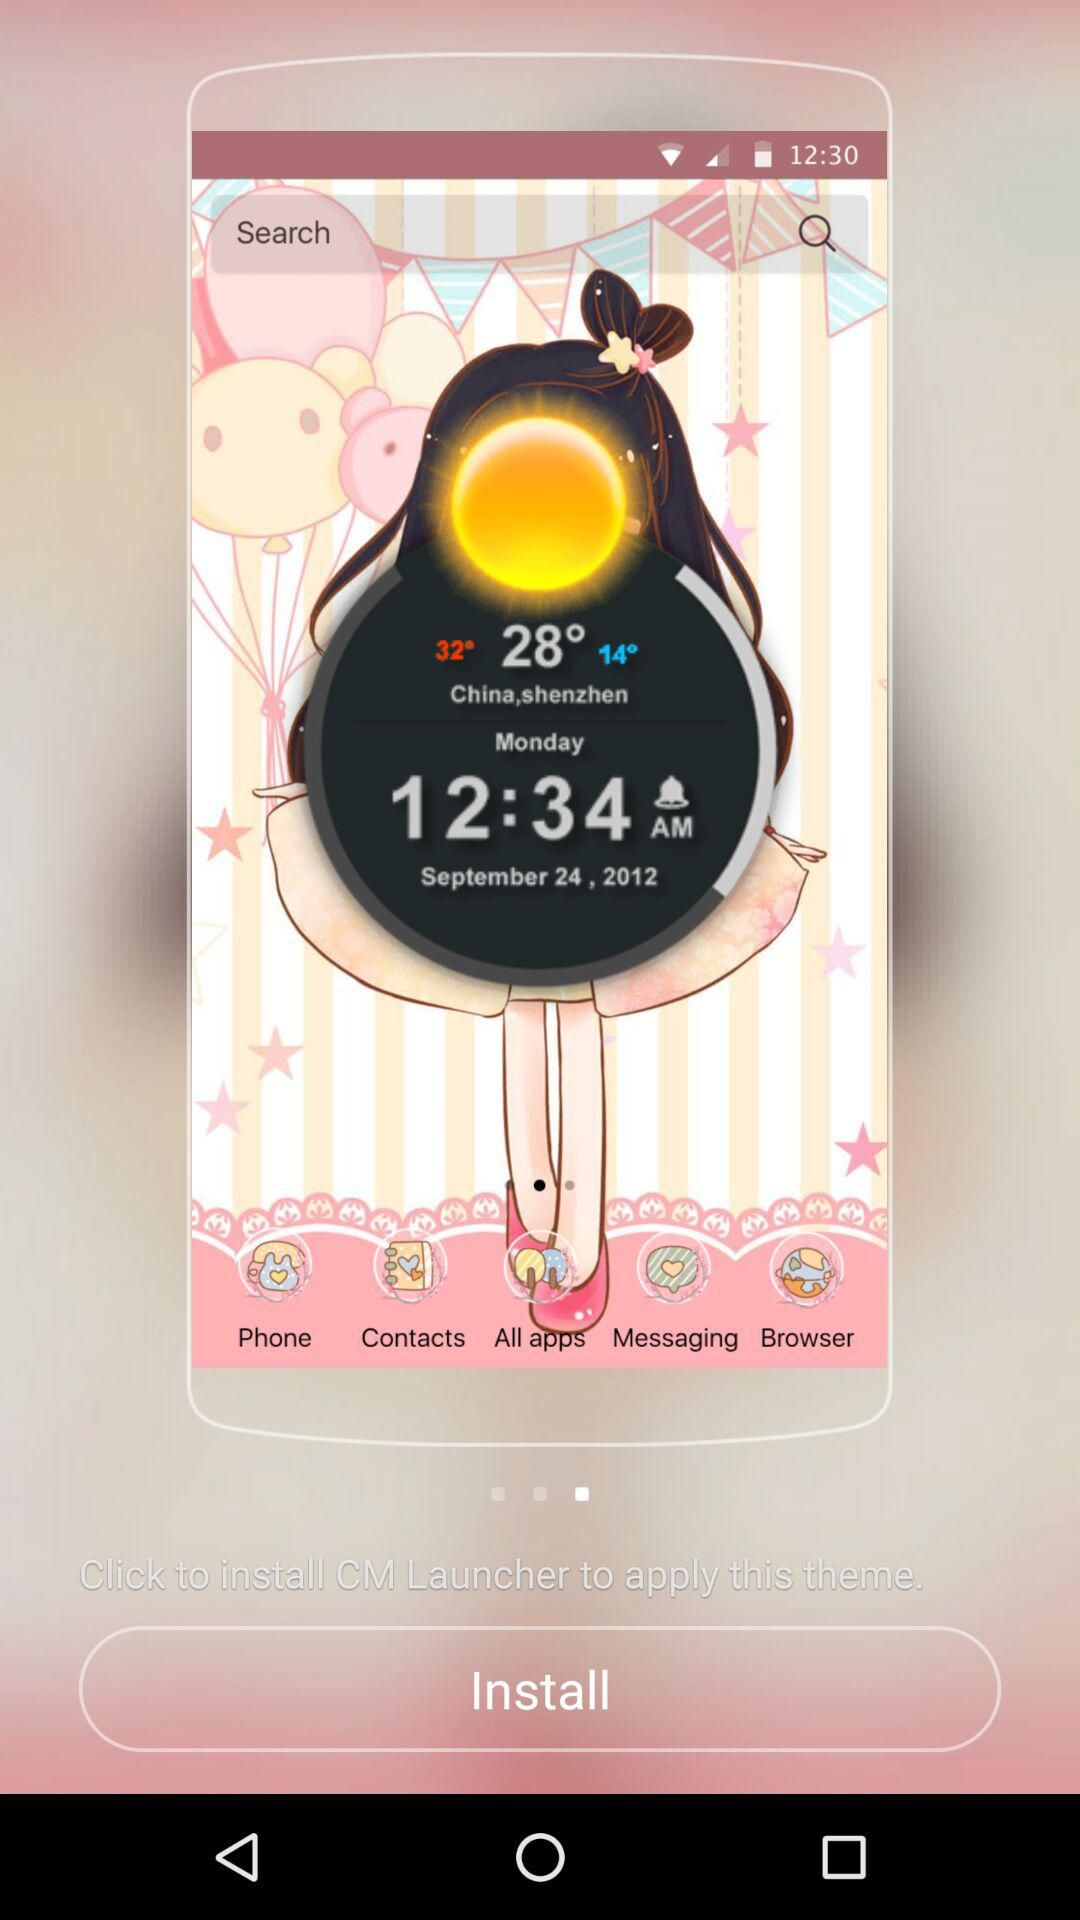What is the date? The date is Monday, September 24, 2012. 